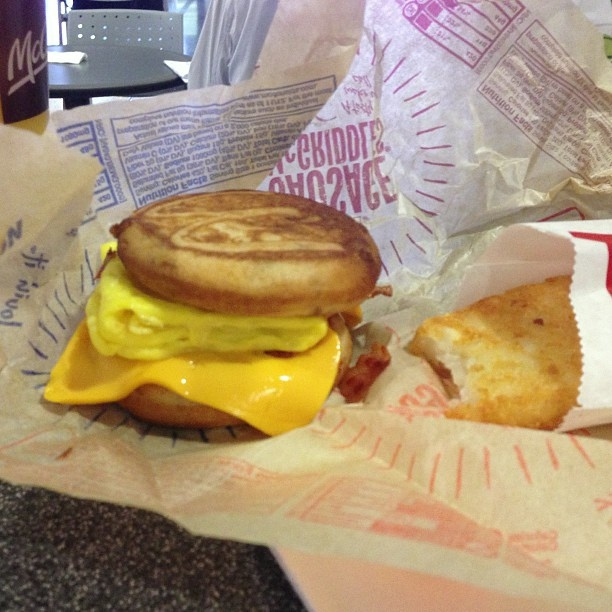Describe the objects in this image and their specific colors. I can see dining table in purple, tan, and darkgray tones, sandwich in purple, olive, gold, and tan tones, sandwich in purple, olive, tan, and orange tones, dining table in purple, gray, and black tones, and cup in purple, black, and gray tones in this image. 